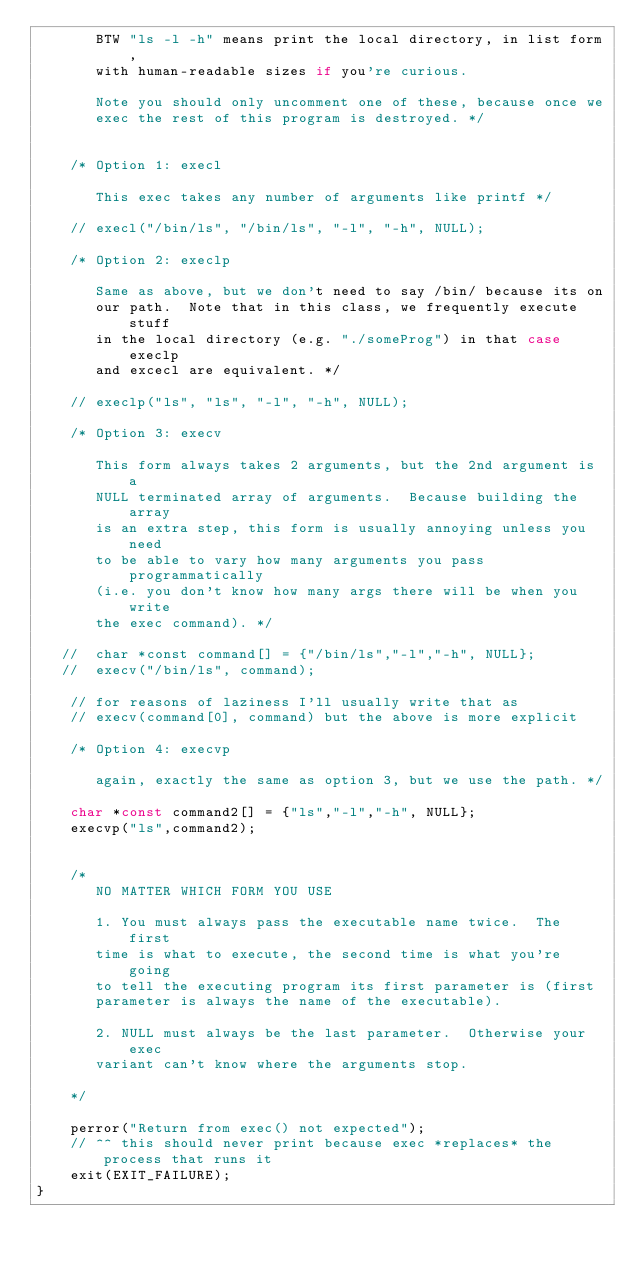Convert code to text. <code><loc_0><loc_0><loc_500><loc_500><_C_>       BTW "ls -l -h" means print the local directory, in list form,
       with human-readable sizes if you're curious.

       Note you should only uncomment one of these, because once we
       exec the rest of this program is destroyed. */


    /* Option 1: execl

       This exec takes any number of arguments like printf */

    // execl("/bin/ls", "/bin/ls", "-l", "-h", NULL);

    /* Option 2: execlp 

       Same as above, but we don't need to say /bin/ because its on
       our path.  Note that in this class, we frequently execute stuff
       in the local directory (e.g. "./someProg") in that case execlp
       and excecl are equivalent. */

    // execlp("ls", "ls", "-l", "-h", NULL);

    /* Option 3: execv 
       
       This form always takes 2 arguments, but the 2nd argument is a
       NULL terminated array of arguments.  Because building the array
       is an extra step, this form is usually annoying unless you need
       to be able to vary how many arguments you pass programmatically
       (i.e. you don't know how many args there will be when you write
       the exec command). */
    
   //  char *const command[] = {"/bin/ls","-l","-h", NULL};
   //  execv("/bin/ls", command);

    // for reasons of laziness I'll usually write that as
    // execv(command[0], command) but the above is more explicit

    /* Option 4: execvp 
       
       again, exactly the same as option 3, but we use the path. */

    char *const command2[] = {"ls","-l","-h", NULL};
    execvp("ls",command2);

    
    /* 
       NO MATTER WHICH FORM YOU USE

       1. You must always pass the executable name twice.  The first
       time is what to execute, the second time is what you're going
       to tell the executing program its first parameter is (first
       parameter is always the name of the executable).

       2. NULL must always be the last parameter.  Otherwise your exec
       variant can't know where the arguments stop.
    
    */
    
    perror("Return from exec() not expected");
    // ^^ this should never print because exec *replaces* the process that runs it
    exit(EXIT_FAILURE);
}

</code> 